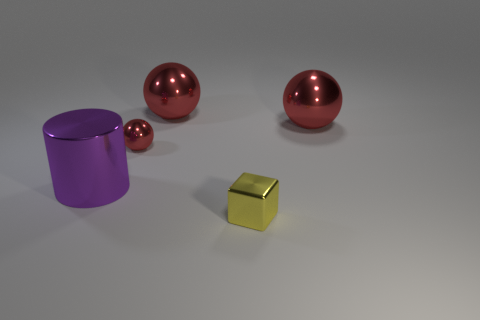What might be the purpose of displaying these objects together? The display appears to be designed to highlight differences in geometric shapes and the effects of light on reflective surfaces. The arrangement seems artistic, possibly intended for visualization, three-dimensional modeling, or graphic design purposes. 